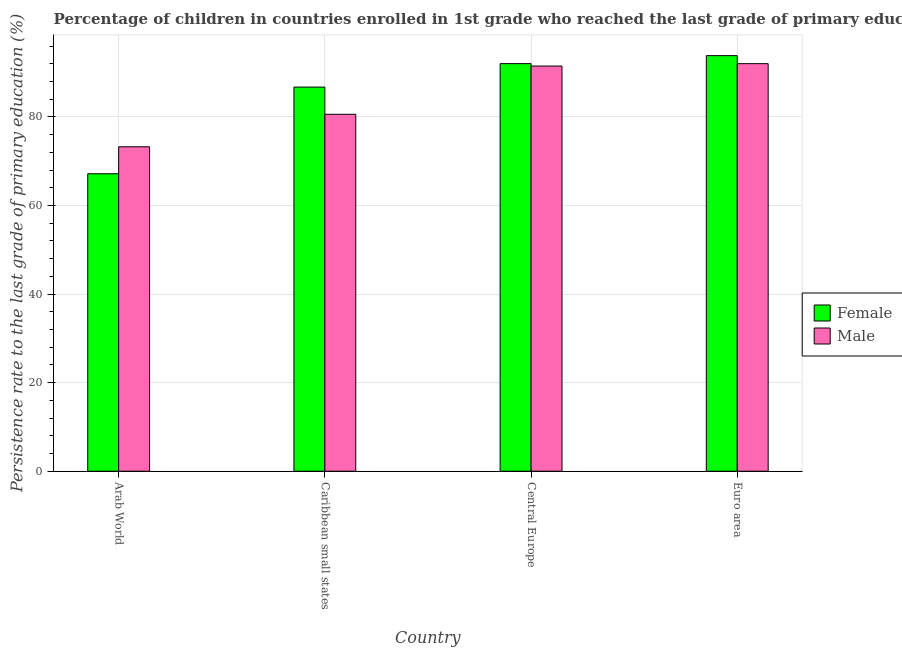How many different coloured bars are there?
Your response must be concise. 2. How many groups of bars are there?
Give a very brief answer. 4. Are the number of bars per tick equal to the number of legend labels?
Provide a short and direct response. Yes. Are the number of bars on each tick of the X-axis equal?
Keep it short and to the point. Yes. What is the label of the 1st group of bars from the left?
Ensure brevity in your answer.  Arab World. What is the persistence rate of female students in Euro area?
Offer a very short reply. 93.85. Across all countries, what is the maximum persistence rate of male students?
Provide a succinct answer. 92.04. Across all countries, what is the minimum persistence rate of female students?
Provide a succinct answer. 67.18. In which country was the persistence rate of female students maximum?
Make the answer very short. Euro area. In which country was the persistence rate of female students minimum?
Make the answer very short. Arab World. What is the total persistence rate of male students in the graph?
Offer a terse response. 337.42. What is the difference between the persistence rate of female students in Arab World and that in Caribbean small states?
Your response must be concise. -19.57. What is the difference between the persistence rate of female students in Arab World and the persistence rate of male students in Central Europe?
Provide a short and direct response. -24.32. What is the average persistence rate of male students per country?
Provide a short and direct response. 84.35. What is the difference between the persistence rate of female students and persistence rate of male students in Caribbean small states?
Keep it short and to the point. 6.14. What is the ratio of the persistence rate of female students in Caribbean small states to that in Euro area?
Your response must be concise. 0.92. Is the persistence rate of female students in Arab World less than that in Caribbean small states?
Your response must be concise. Yes. What is the difference between the highest and the second highest persistence rate of male students?
Make the answer very short. 0.54. What is the difference between the highest and the lowest persistence rate of male students?
Make the answer very short. 18.77. Is the sum of the persistence rate of female students in Arab World and Euro area greater than the maximum persistence rate of male students across all countries?
Your response must be concise. Yes. What does the 1st bar from the left in Euro area represents?
Make the answer very short. Female. How many countries are there in the graph?
Make the answer very short. 4. Are the values on the major ticks of Y-axis written in scientific E-notation?
Provide a short and direct response. No. Where does the legend appear in the graph?
Your response must be concise. Center right. What is the title of the graph?
Give a very brief answer. Percentage of children in countries enrolled in 1st grade who reached the last grade of primary education. Does "Investment in Telecom" appear as one of the legend labels in the graph?
Provide a short and direct response. No. What is the label or title of the X-axis?
Provide a short and direct response. Country. What is the label or title of the Y-axis?
Give a very brief answer. Persistence rate to the last grade of primary education (%). What is the Persistence rate to the last grade of primary education (%) in Female in Arab World?
Give a very brief answer. 67.18. What is the Persistence rate to the last grade of primary education (%) in Male in Arab World?
Keep it short and to the point. 73.27. What is the Persistence rate to the last grade of primary education (%) of Female in Caribbean small states?
Offer a very short reply. 86.75. What is the Persistence rate to the last grade of primary education (%) of Male in Caribbean small states?
Give a very brief answer. 80.61. What is the Persistence rate to the last grade of primary education (%) of Female in Central Europe?
Give a very brief answer. 92.05. What is the Persistence rate to the last grade of primary education (%) of Male in Central Europe?
Your answer should be compact. 91.5. What is the Persistence rate to the last grade of primary education (%) of Female in Euro area?
Your answer should be very brief. 93.85. What is the Persistence rate to the last grade of primary education (%) of Male in Euro area?
Make the answer very short. 92.04. Across all countries, what is the maximum Persistence rate to the last grade of primary education (%) in Female?
Make the answer very short. 93.85. Across all countries, what is the maximum Persistence rate to the last grade of primary education (%) in Male?
Give a very brief answer. 92.04. Across all countries, what is the minimum Persistence rate to the last grade of primary education (%) of Female?
Offer a very short reply. 67.18. Across all countries, what is the minimum Persistence rate to the last grade of primary education (%) of Male?
Provide a short and direct response. 73.27. What is the total Persistence rate to the last grade of primary education (%) in Female in the graph?
Give a very brief answer. 339.82. What is the total Persistence rate to the last grade of primary education (%) in Male in the graph?
Ensure brevity in your answer.  337.42. What is the difference between the Persistence rate to the last grade of primary education (%) in Female in Arab World and that in Caribbean small states?
Offer a very short reply. -19.57. What is the difference between the Persistence rate to the last grade of primary education (%) in Male in Arab World and that in Caribbean small states?
Make the answer very short. -7.34. What is the difference between the Persistence rate to the last grade of primary education (%) of Female in Arab World and that in Central Europe?
Make the answer very short. -24.87. What is the difference between the Persistence rate to the last grade of primary education (%) in Male in Arab World and that in Central Europe?
Your answer should be very brief. -18.23. What is the difference between the Persistence rate to the last grade of primary education (%) in Female in Arab World and that in Euro area?
Your answer should be very brief. -26.67. What is the difference between the Persistence rate to the last grade of primary education (%) of Male in Arab World and that in Euro area?
Give a very brief answer. -18.77. What is the difference between the Persistence rate to the last grade of primary education (%) of Female in Caribbean small states and that in Central Europe?
Your answer should be very brief. -5.3. What is the difference between the Persistence rate to the last grade of primary education (%) of Male in Caribbean small states and that in Central Europe?
Your response must be concise. -10.89. What is the difference between the Persistence rate to the last grade of primary education (%) of Female in Caribbean small states and that in Euro area?
Provide a short and direct response. -7.1. What is the difference between the Persistence rate to the last grade of primary education (%) of Male in Caribbean small states and that in Euro area?
Provide a succinct answer. -11.43. What is the difference between the Persistence rate to the last grade of primary education (%) in Female in Central Europe and that in Euro area?
Make the answer very short. -1.8. What is the difference between the Persistence rate to the last grade of primary education (%) of Male in Central Europe and that in Euro area?
Provide a short and direct response. -0.54. What is the difference between the Persistence rate to the last grade of primary education (%) of Female in Arab World and the Persistence rate to the last grade of primary education (%) of Male in Caribbean small states?
Offer a very short reply. -13.43. What is the difference between the Persistence rate to the last grade of primary education (%) of Female in Arab World and the Persistence rate to the last grade of primary education (%) of Male in Central Europe?
Provide a succinct answer. -24.32. What is the difference between the Persistence rate to the last grade of primary education (%) in Female in Arab World and the Persistence rate to the last grade of primary education (%) in Male in Euro area?
Provide a succinct answer. -24.86. What is the difference between the Persistence rate to the last grade of primary education (%) of Female in Caribbean small states and the Persistence rate to the last grade of primary education (%) of Male in Central Europe?
Your answer should be compact. -4.75. What is the difference between the Persistence rate to the last grade of primary education (%) in Female in Caribbean small states and the Persistence rate to the last grade of primary education (%) in Male in Euro area?
Ensure brevity in your answer.  -5.29. What is the difference between the Persistence rate to the last grade of primary education (%) of Female in Central Europe and the Persistence rate to the last grade of primary education (%) of Male in Euro area?
Make the answer very short. 0.01. What is the average Persistence rate to the last grade of primary education (%) in Female per country?
Your answer should be very brief. 84.96. What is the average Persistence rate to the last grade of primary education (%) in Male per country?
Provide a succinct answer. 84.35. What is the difference between the Persistence rate to the last grade of primary education (%) of Female and Persistence rate to the last grade of primary education (%) of Male in Arab World?
Your response must be concise. -6.09. What is the difference between the Persistence rate to the last grade of primary education (%) in Female and Persistence rate to the last grade of primary education (%) in Male in Caribbean small states?
Your response must be concise. 6.14. What is the difference between the Persistence rate to the last grade of primary education (%) in Female and Persistence rate to the last grade of primary education (%) in Male in Central Europe?
Make the answer very short. 0.55. What is the difference between the Persistence rate to the last grade of primary education (%) of Female and Persistence rate to the last grade of primary education (%) of Male in Euro area?
Keep it short and to the point. 1.81. What is the ratio of the Persistence rate to the last grade of primary education (%) in Female in Arab World to that in Caribbean small states?
Your answer should be very brief. 0.77. What is the ratio of the Persistence rate to the last grade of primary education (%) in Male in Arab World to that in Caribbean small states?
Offer a terse response. 0.91. What is the ratio of the Persistence rate to the last grade of primary education (%) in Female in Arab World to that in Central Europe?
Provide a short and direct response. 0.73. What is the ratio of the Persistence rate to the last grade of primary education (%) of Male in Arab World to that in Central Europe?
Keep it short and to the point. 0.8. What is the ratio of the Persistence rate to the last grade of primary education (%) of Female in Arab World to that in Euro area?
Provide a short and direct response. 0.72. What is the ratio of the Persistence rate to the last grade of primary education (%) in Male in Arab World to that in Euro area?
Provide a short and direct response. 0.8. What is the ratio of the Persistence rate to the last grade of primary education (%) of Female in Caribbean small states to that in Central Europe?
Ensure brevity in your answer.  0.94. What is the ratio of the Persistence rate to the last grade of primary education (%) of Male in Caribbean small states to that in Central Europe?
Keep it short and to the point. 0.88. What is the ratio of the Persistence rate to the last grade of primary education (%) of Female in Caribbean small states to that in Euro area?
Provide a short and direct response. 0.92. What is the ratio of the Persistence rate to the last grade of primary education (%) in Male in Caribbean small states to that in Euro area?
Offer a very short reply. 0.88. What is the ratio of the Persistence rate to the last grade of primary education (%) in Female in Central Europe to that in Euro area?
Provide a succinct answer. 0.98. What is the difference between the highest and the second highest Persistence rate to the last grade of primary education (%) of Female?
Keep it short and to the point. 1.8. What is the difference between the highest and the second highest Persistence rate to the last grade of primary education (%) of Male?
Ensure brevity in your answer.  0.54. What is the difference between the highest and the lowest Persistence rate to the last grade of primary education (%) in Female?
Offer a terse response. 26.67. What is the difference between the highest and the lowest Persistence rate to the last grade of primary education (%) of Male?
Your answer should be compact. 18.77. 